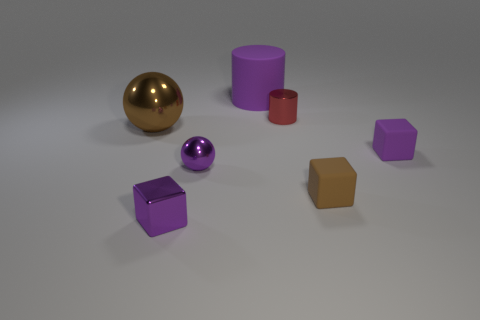How many tiny red things have the same material as the big purple cylinder?
Make the answer very short. 0. Are there fewer small blocks than large metallic objects?
Your response must be concise. No. There is a small rubber object that is behind the small brown block; does it have the same color as the small ball?
Offer a terse response. Yes. There is a small metal sphere that is left of the brown object that is to the right of the purple cylinder; what number of shiny balls are in front of it?
Your answer should be compact. 0. There is a small brown thing; how many big matte things are on the left side of it?
Offer a very short reply. 1. What color is the metal object that is the same shape as the brown matte object?
Offer a very short reply. Purple. The purple thing that is both to the left of the large purple object and behind the brown matte thing is made of what material?
Ensure brevity in your answer.  Metal. Do the cylinder that is in front of the purple rubber cylinder and the big cylinder have the same size?
Offer a terse response. No. What material is the small red cylinder?
Provide a short and direct response. Metal. What is the color of the matte thing that is right of the small brown thing?
Your answer should be very brief. Purple. 